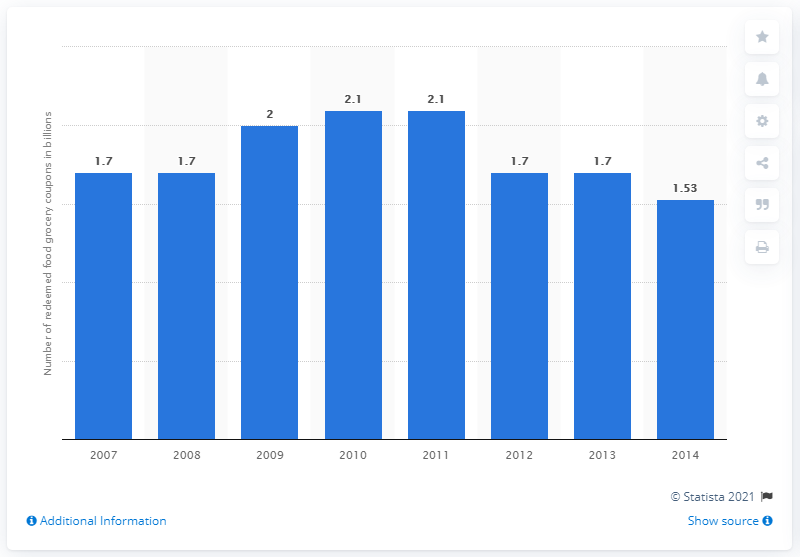Indicate a few pertinent items in this graphic. In 2011, a total of 2.1 million food coupons were redeemed in the United States. In 2007, a total of 1.7 food coupons were redeemed. 